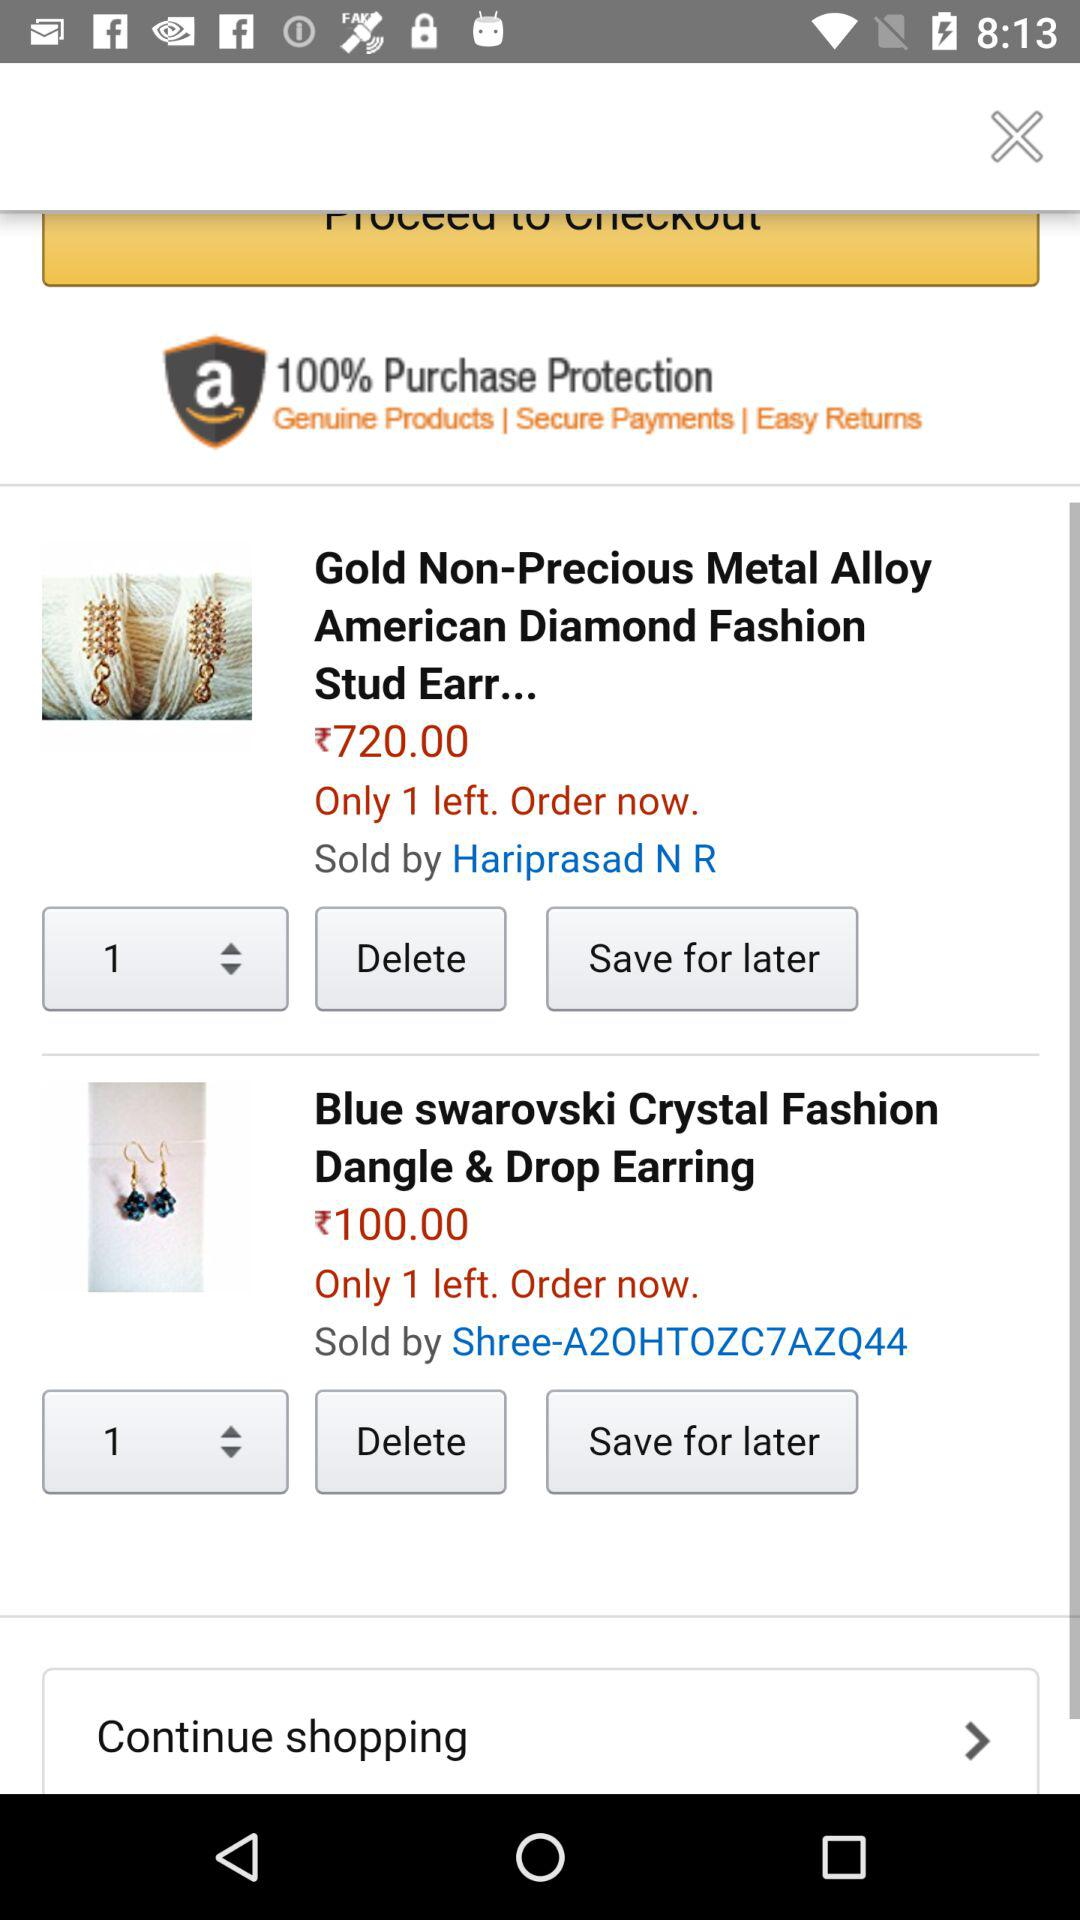How much is the tax on the blue Swarovski earrings?
When the provided information is insufficient, respond with <no answer>. <no answer> 